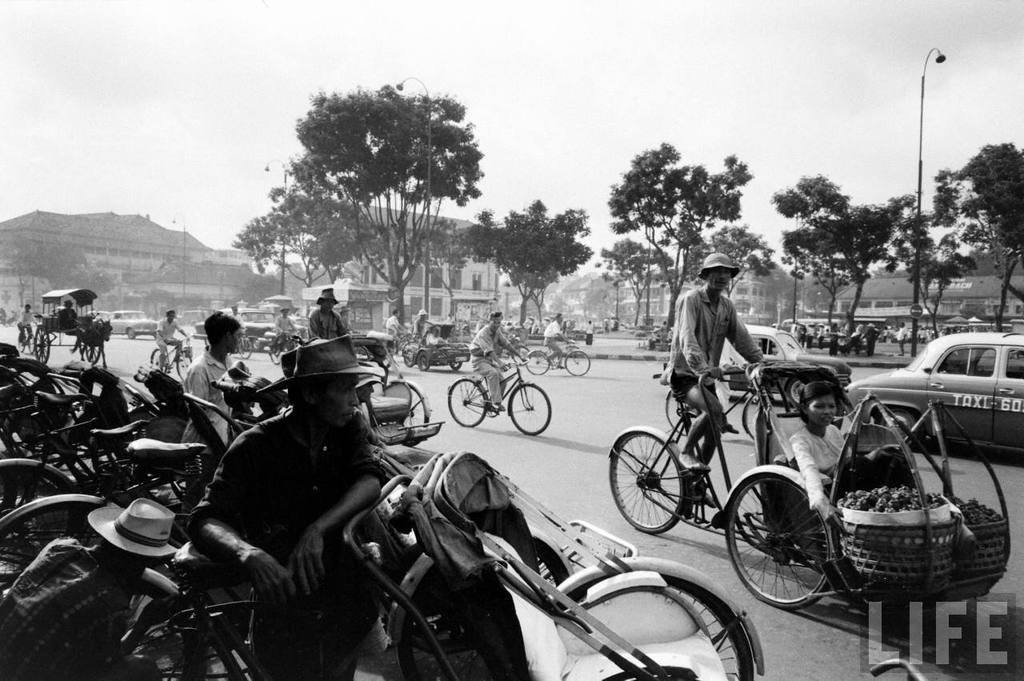What type of transportation can be seen in the image? There are bicycles, cars, and other vehicles in the image. What are the vehicles doing in the image? The vehicles are passing on a road. What can be seen in the background of the image? There are trees and buildings in the background of the image. Is there an umbrella being used to expand the road in the image? There is no umbrella present in the image, and it is not being used to expand the road. 